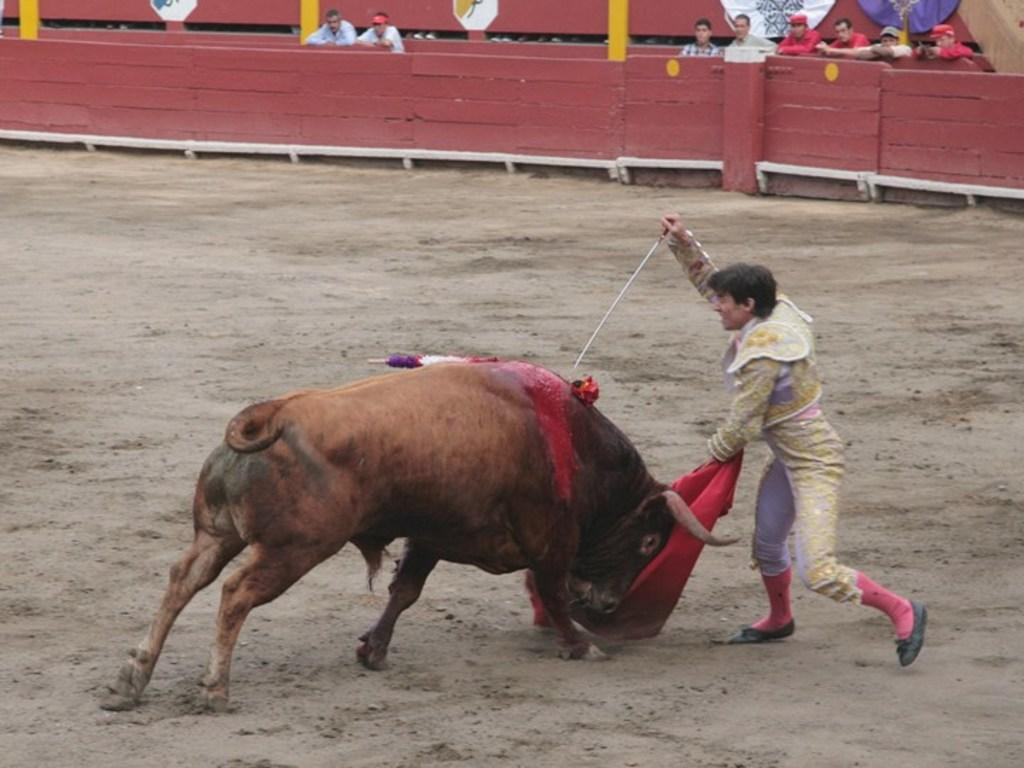What is the man in the image holding? The man is holding a sword and a red color cloth. What is the man standing near in the image? There is a bull in the image. What can be seen in the background of the image? There are people standing and a fence in the background of the image. What type of bait is the man using to catch the plane in the image? There is no plane present in the image, and the man is not using any bait. 